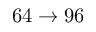Convert formula to latex. <formula><loc_0><loc_0><loc_500><loc_500>6 4 \to 9 6</formula> 